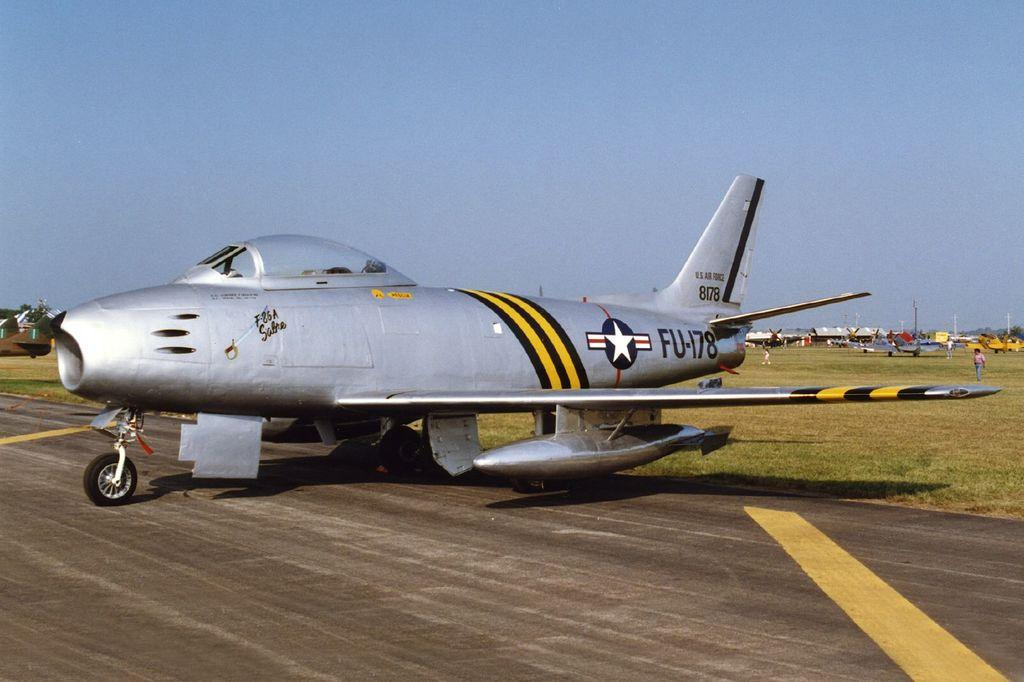<image>
Share a concise interpretation of the image provided. An FU-178 jet is resting near the edge of a runway 